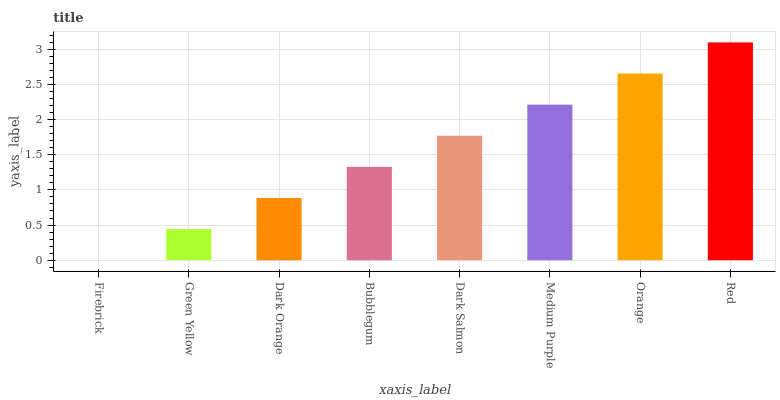Is Firebrick the minimum?
Answer yes or no. Yes. Is Red the maximum?
Answer yes or no. Yes. Is Green Yellow the minimum?
Answer yes or no. No. Is Green Yellow the maximum?
Answer yes or no. No. Is Green Yellow greater than Firebrick?
Answer yes or no. Yes. Is Firebrick less than Green Yellow?
Answer yes or no. Yes. Is Firebrick greater than Green Yellow?
Answer yes or no. No. Is Green Yellow less than Firebrick?
Answer yes or no. No. Is Dark Salmon the high median?
Answer yes or no. Yes. Is Bubblegum the low median?
Answer yes or no. Yes. Is Dark Orange the high median?
Answer yes or no. No. Is Orange the low median?
Answer yes or no. No. 